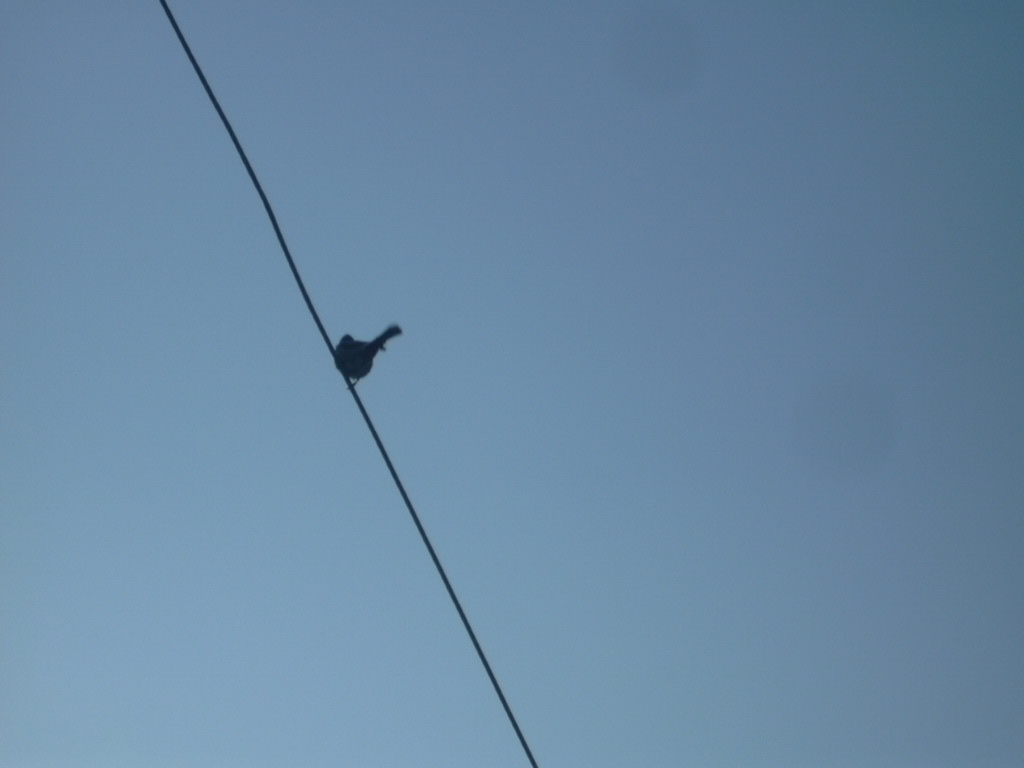Are there any quality issues with this image? Yes, the image appears to be underexposed, which has resulted in the sky appearing overly bright and the subject, which is a bird on a wire, being in silhouette. The focus seems soft, and there's a lack of sharp detail visible in the image. 